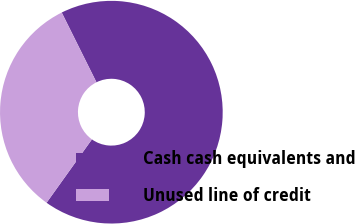<chart> <loc_0><loc_0><loc_500><loc_500><pie_chart><fcel>Cash cash equivalents and<fcel>Unused line of credit<nl><fcel>67.24%<fcel>32.76%<nl></chart> 